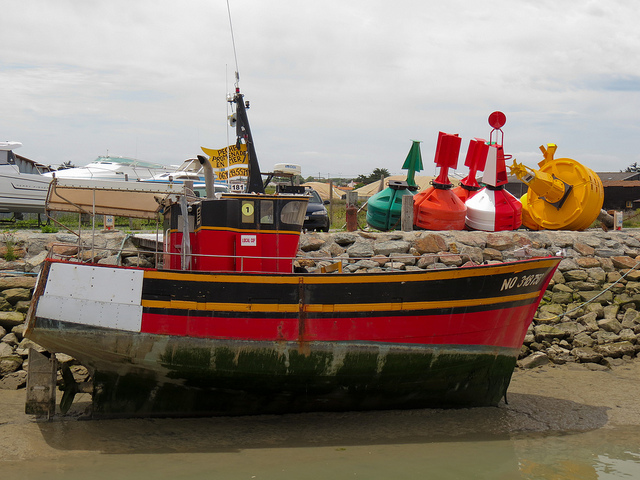Please extract the text content from this image. 1 NO 